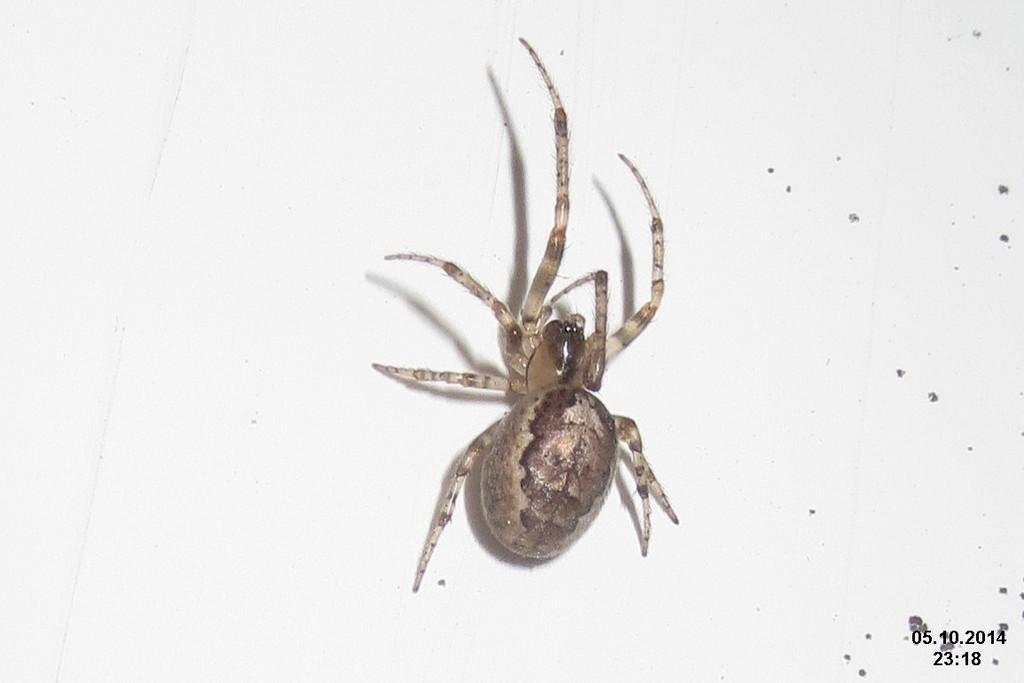Can you describe this image briefly? In the middle of this image, there is a spider on a surface. On the bottom right, there is a watermark. And the background is white in color. 